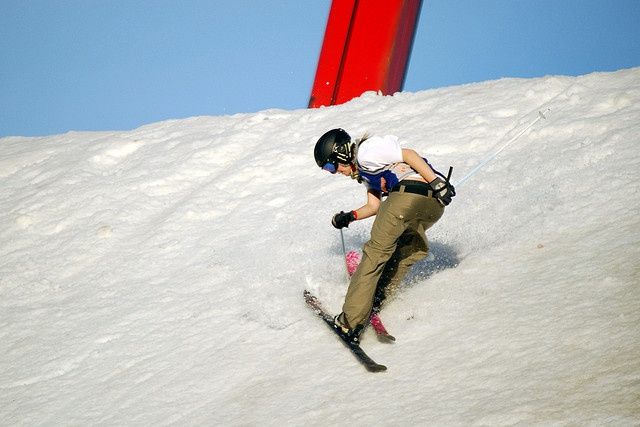Describe the objects in this image and their specific colors. I can see people in darkgray, black, and olive tones and skis in darkgray, black, gray, and lightpink tones in this image. 